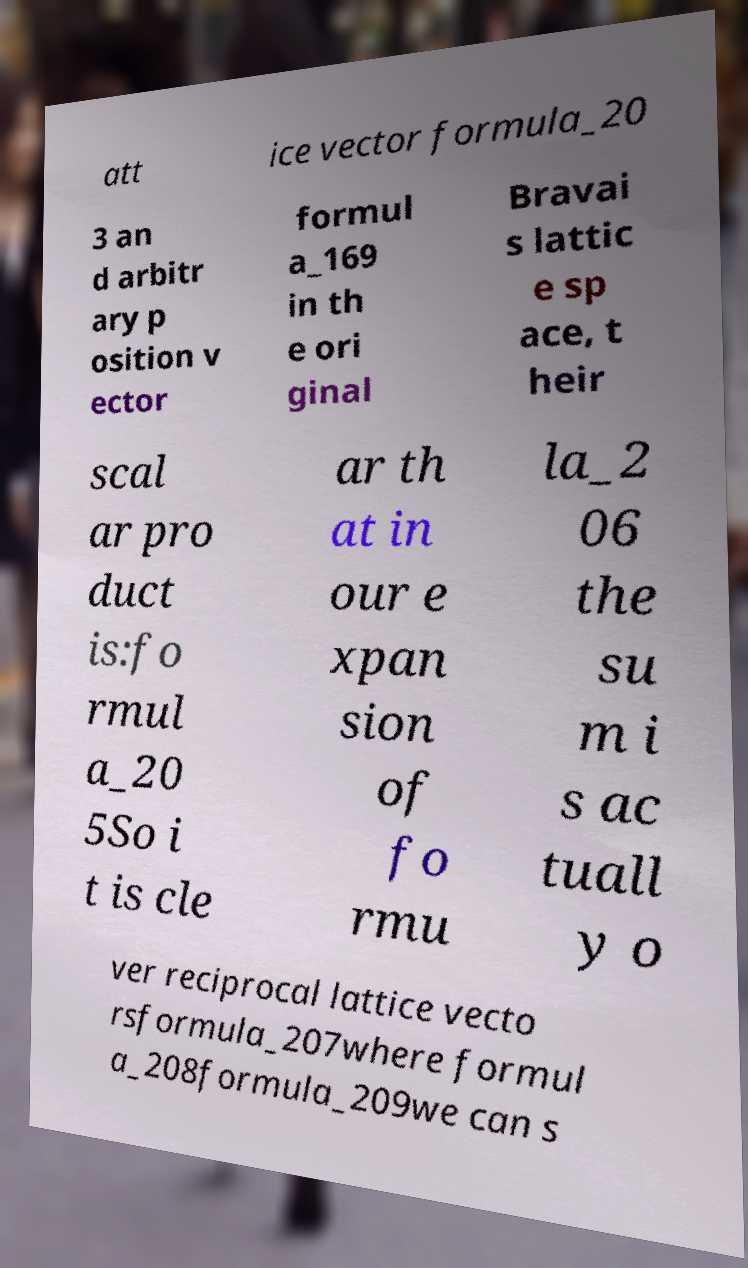For documentation purposes, I need the text within this image transcribed. Could you provide that? att ice vector formula_20 3 an d arbitr ary p osition v ector formul a_169 in th e ori ginal Bravai s lattic e sp ace, t heir scal ar pro duct is:fo rmul a_20 5So i t is cle ar th at in our e xpan sion of fo rmu la_2 06 the su m i s ac tuall y o ver reciprocal lattice vecto rsformula_207where formul a_208formula_209we can s 